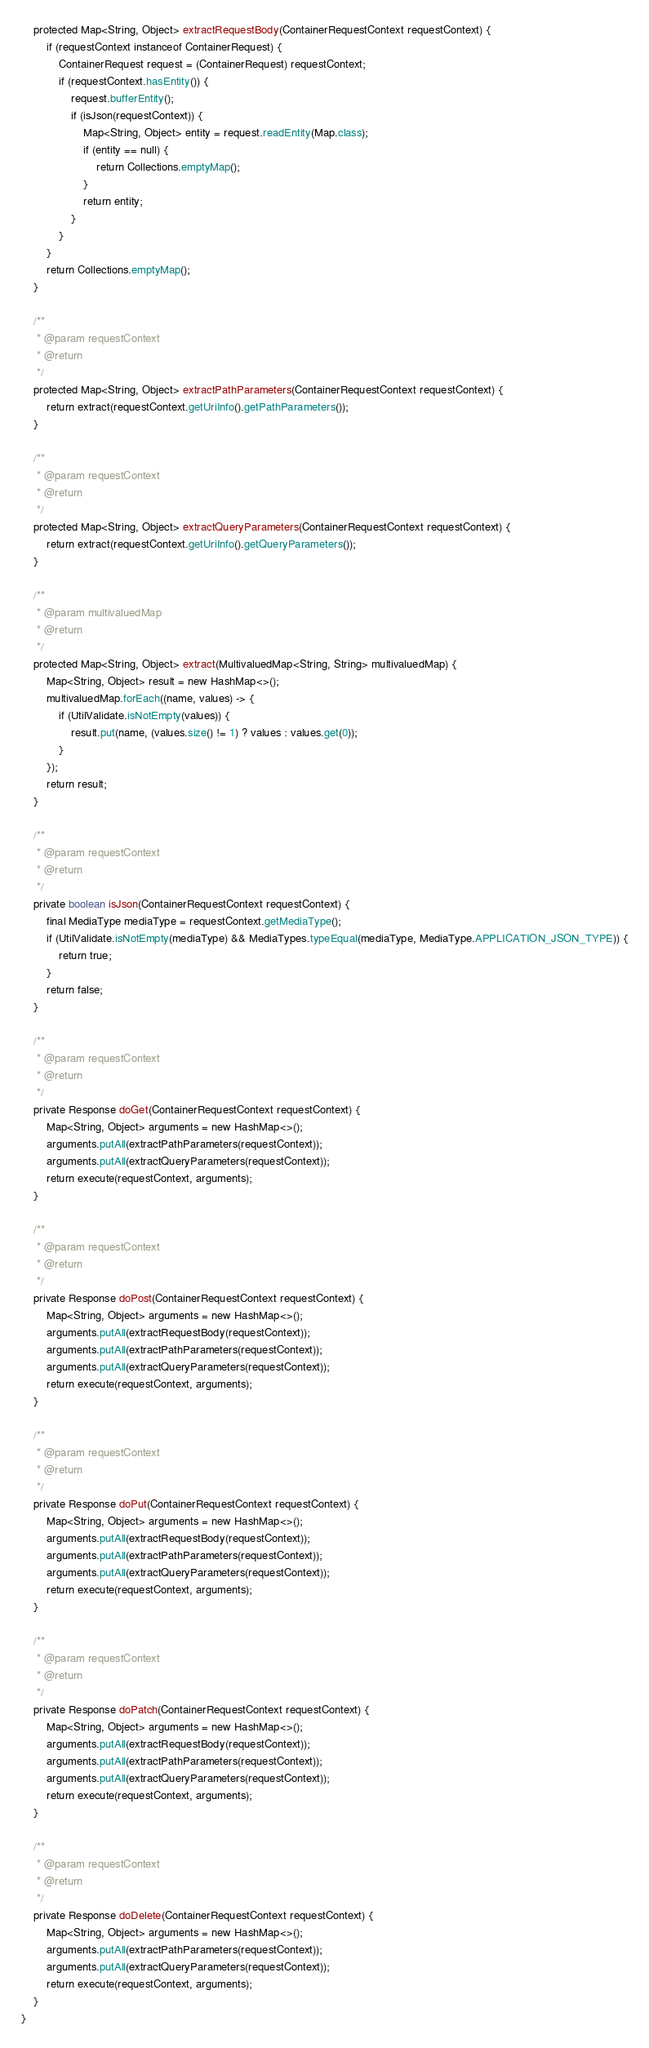Convert code to text. <code><loc_0><loc_0><loc_500><loc_500><_Java_>    protected Map<String, Object> extractRequestBody(ContainerRequestContext requestContext) {
        if (requestContext instanceof ContainerRequest) {
            ContainerRequest request = (ContainerRequest) requestContext;
            if (requestContext.hasEntity()) {
                request.bufferEntity();
                if (isJson(requestContext)) {
                    Map<String, Object> entity = request.readEntity(Map.class);
                    if (entity == null) {
                        return Collections.emptyMap();
                    }
                    return entity;
                }
            }
        }
        return Collections.emptyMap();
    }

    /**
     * @param requestContext
     * @return
     */
    protected Map<String, Object> extractPathParameters(ContainerRequestContext requestContext) {
        return extract(requestContext.getUriInfo().getPathParameters());
    }

    /**
     * @param requestContext
     * @return
     */
    protected Map<String, Object> extractQueryParameters(ContainerRequestContext requestContext) {
        return extract(requestContext.getUriInfo().getQueryParameters());
    }

    /**
     * @param multivaluedMap
     * @return
     */
    protected Map<String, Object> extract(MultivaluedMap<String, String> multivaluedMap) {
        Map<String, Object> result = new HashMap<>();
        multivaluedMap.forEach((name, values) -> {
            if (UtilValidate.isNotEmpty(values)) {
                result.put(name, (values.size() != 1) ? values : values.get(0));
            }
        });
        return result;
    }

    /**
     * @param requestContext
     * @return
     */
    private boolean isJson(ContainerRequestContext requestContext) {
        final MediaType mediaType = requestContext.getMediaType();
        if (UtilValidate.isNotEmpty(mediaType) && MediaTypes.typeEqual(mediaType, MediaType.APPLICATION_JSON_TYPE)) {
            return true;
        }
        return false;
    }

    /**
     * @param requestContext
     * @return
     */
    private Response doGet(ContainerRequestContext requestContext) {
        Map<String, Object> arguments = new HashMap<>();
        arguments.putAll(extractPathParameters(requestContext));
        arguments.putAll(extractQueryParameters(requestContext));
        return execute(requestContext, arguments);
    }

    /**
     * @param requestContext
     * @return
     */
    private Response doPost(ContainerRequestContext requestContext) {
        Map<String, Object> arguments = new HashMap<>();
        arguments.putAll(extractRequestBody(requestContext));
        arguments.putAll(extractPathParameters(requestContext));
        arguments.putAll(extractQueryParameters(requestContext));
        return execute(requestContext, arguments);
    }

    /**
     * @param requestContext
     * @return
     */
    private Response doPut(ContainerRequestContext requestContext) {
        Map<String, Object> arguments = new HashMap<>();
        arguments.putAll(extractRequestBody(requestContext));
        arguments.putAll(extractPathParameters(requestContext));
        arguments.putAll(extractQueryParameters(requestContext));
        return execute(requestContext, arguments);
    }

    /**
     * @param requestContext
     * @return
     */
    private Response doPatch(ContainerRequestContext requestContext) {
        Map<String, Object> arguments = new HashMap<>();
        arguments.putAll(extractRequestBody(requestContext));
        arguments.putAll(extractPathParameters(requestContext));
        arguments.putAll(extractQueryParameters(requestContext));
        return execute(requestContext, arguments);
    }

    /**
     * @param requestContext
     * @return
     */
    private Response doDelete(ContainerRequestContext requestContext) {
        Map<String, Object> arguments = new HashMap<>();
        arguments.putAll(extractPathParameters(requestContext));
        arguments.putAll(extractQueryParameters(requestContext));
        return execute(requestContext, arguments);
    }
}
</code> 